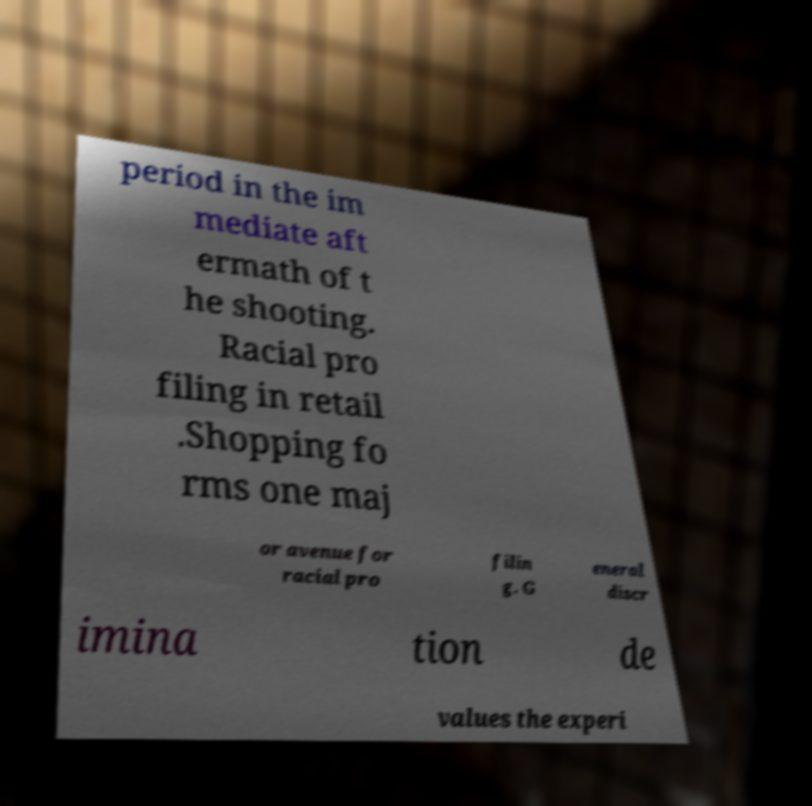Could you assist in decoding the text presented in this image and type it out clearly? period in the im mediate aft ermath of t he shooting. Racial pro filing in retail .Shopping fo rms one maj or avenue for racial pro filin g. G eneral discr imina tion de values the experi 